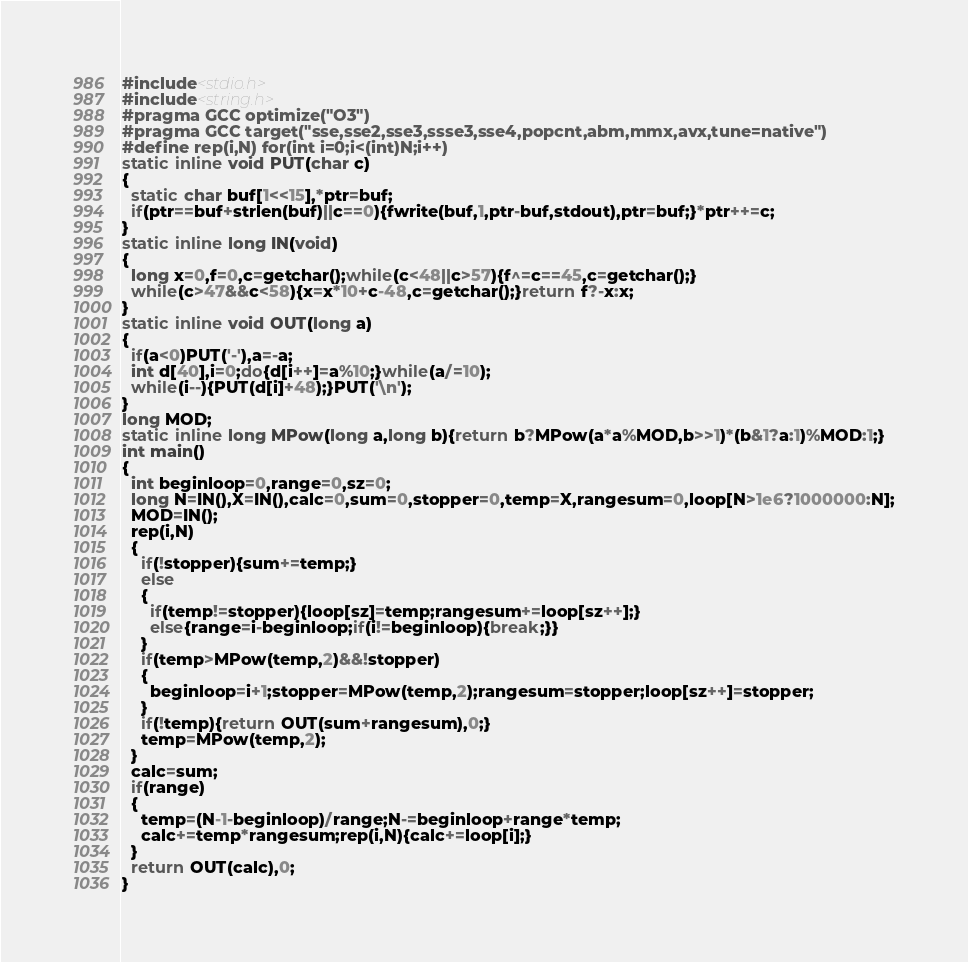Convert code to text. <code><loc_0><loc_0><loc_500><loc_500><_C++_>#include<stdio.h>
#include<string.h>
#pragma GCC optimize("O3")
#pragma GCC target("sse,sse2,sse3,ssse3,sse4,popcnt,abm,mmx,avx,tune=native")
#define rep(i,N) for(int i=0;i<(int)N;i++)
static inline void PUT(char c)
{
  static char buf[1<<15],*ptr=buf;
  if(ptr==buf+strlen(buf)||c==0){fwrite(buf,1,ptr-buf,stdout),ptr=buf;}*ptr++=c;
}
static inline long IN(void)
{
  long x=0,f=0,c=getchar();while(c<48||c>57){f^=c==45,c=getchar();}
  while(c>47&&c<58){x=x*10+c-48,c=getchar();}return f?-x:x;
}
static inline void OUT(long a)
{
  if(a<0)PUT('-'),a=-a;
  int d[40],i=0;do{d[i++]=a%10;}while(a/=10);
  while(i--){PUT(d[i]+48);}PUT('\n');
}
long MOD;
static inline long MPow(long a,long b){return b?MPow(a*a%MOD,b>>1)*(b&1?a:1)%MOD:1;}
int main()
{
  int beginloop=0,range=0,sz=0;
  long N=IN(),X=IN(),calc=0,sum=0,stopper=0,temp=X,rangesum=0,loop[N>1e6?1000000:N];
  MOD=IN();
  rep(i,N)
  {
    if(!stopper){sum+=temp;}
    else
    {
      if(temp!=stopper){loop[sz]=temp;rangesum+=loop[sz++];}
      else{range=i-beginloop;if(i!=beginloop){break;}}
    }
    if(temp>MPow(temp,2)&&!stopper)
    {
      beginloop=i+1;stopper=MPow(temp,2);rangesum=stopper;loop[sz++]=stopper;
    }
    if(!temp){return OUT(sum+rangesum),0;}
    temp=MPow(temp,2);
  }
  calc=sum;
  if(range)
  {
    temp=(N-1-beginloop)/range;N-=beginloop+range*temp;
    calc+=temp*rangesum;rep(i,N){calc+=loop[i];}
  }
  return OUT(calc),0;
}</code> 